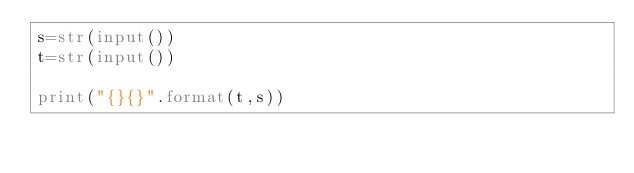Convert code to text. <code><loc_0><loc_0><loc_500><loc_500><_Python_>s=str(input())
t=str(input())

print("{}{}".format(t,s))</code> 